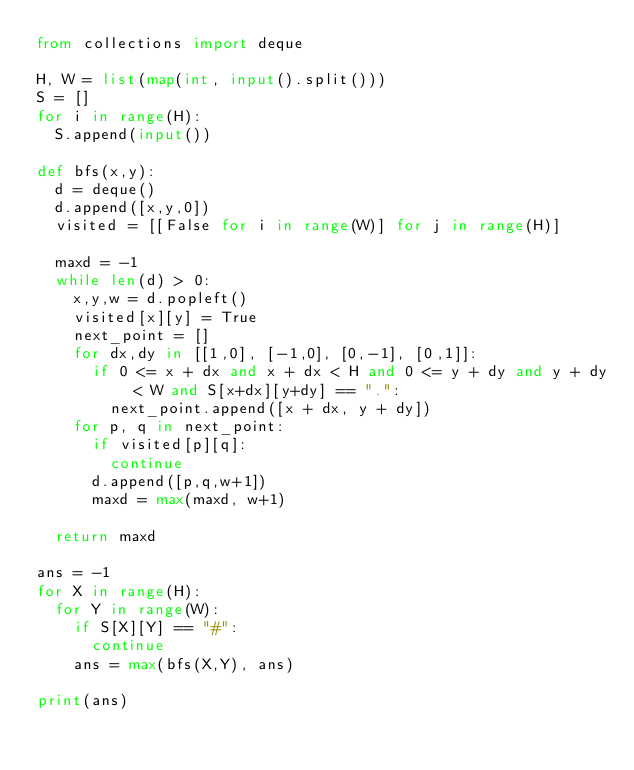<code> <loc_0><loc_0><loc_500><loc_500><_Python_>from collections import deque

H, W = list(map(int, input().split()))
S = []
for i in range(H):
  S.append(input())

def bfs(x,y):
  d = deque()
  d.append([x,y,0])
  visited = [[False for i in range(W)] for j in range(H)]

  maxd = -1
  while len(d) > 0:
    x,y,w = d.popleft()
    visited[x][y] = True
    next_point = []
    for dx,dy in [[1,0], [-1,0], [0,-1], [0,1]]:
      if 0 <= x + dx and x + dx < H and 0 <= y + dy and y + dy < W and S[x+dx][y+dy] == ".":
        next_point.append([x + dx, y + dy])
    for p, q in next_point:
      if visited[p][q]:
        continue
      d.append([p,q,w+1])
      maxd = max(maxd, w+1)

  return maxd

ans = -1
for X in range(H):
  for Y in range(W):
    if S[X][Y] == "#":
      continue
    ans = max(bfs(X,Y), ans)
    
print(ans)</code> 